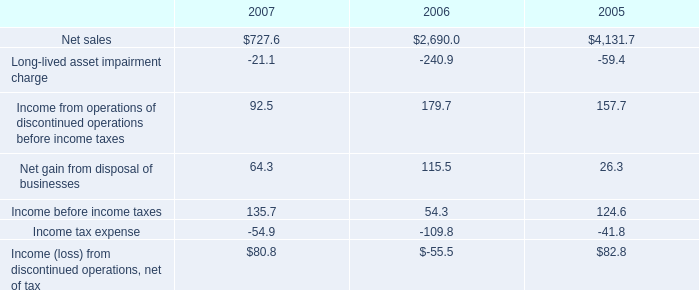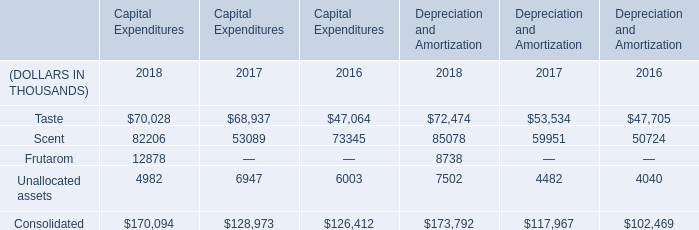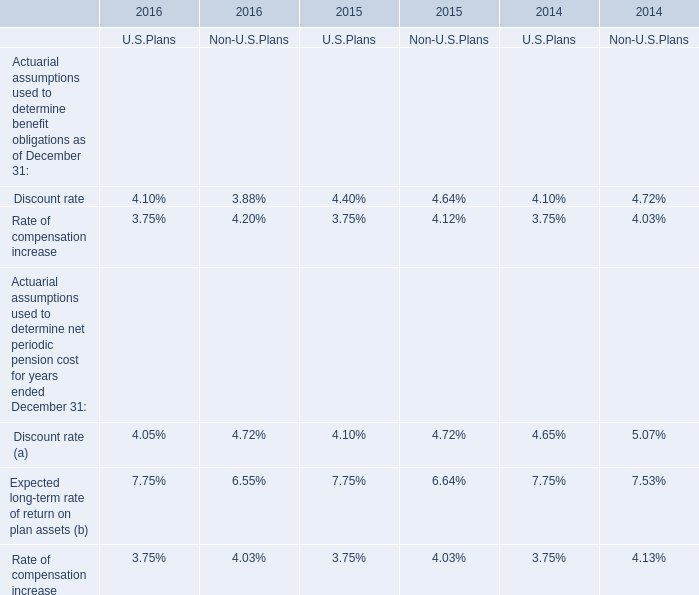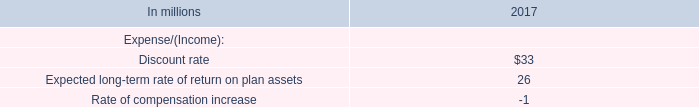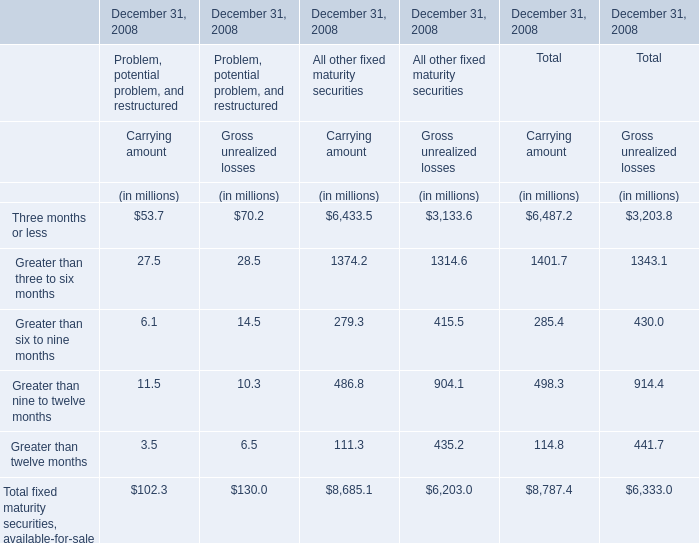Which carrying amount for total exceeds 10% of total in 2008? 
Answer: three months or less and Greater than three to six months. 